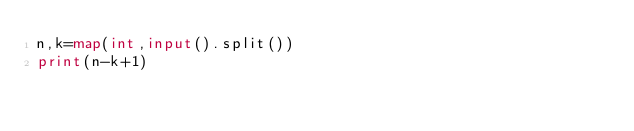<code> <loc_0><loc_0><loc_500><loc_500><_Python_>n,k=map(int,input().split())
print(n-k+1)
</code> 